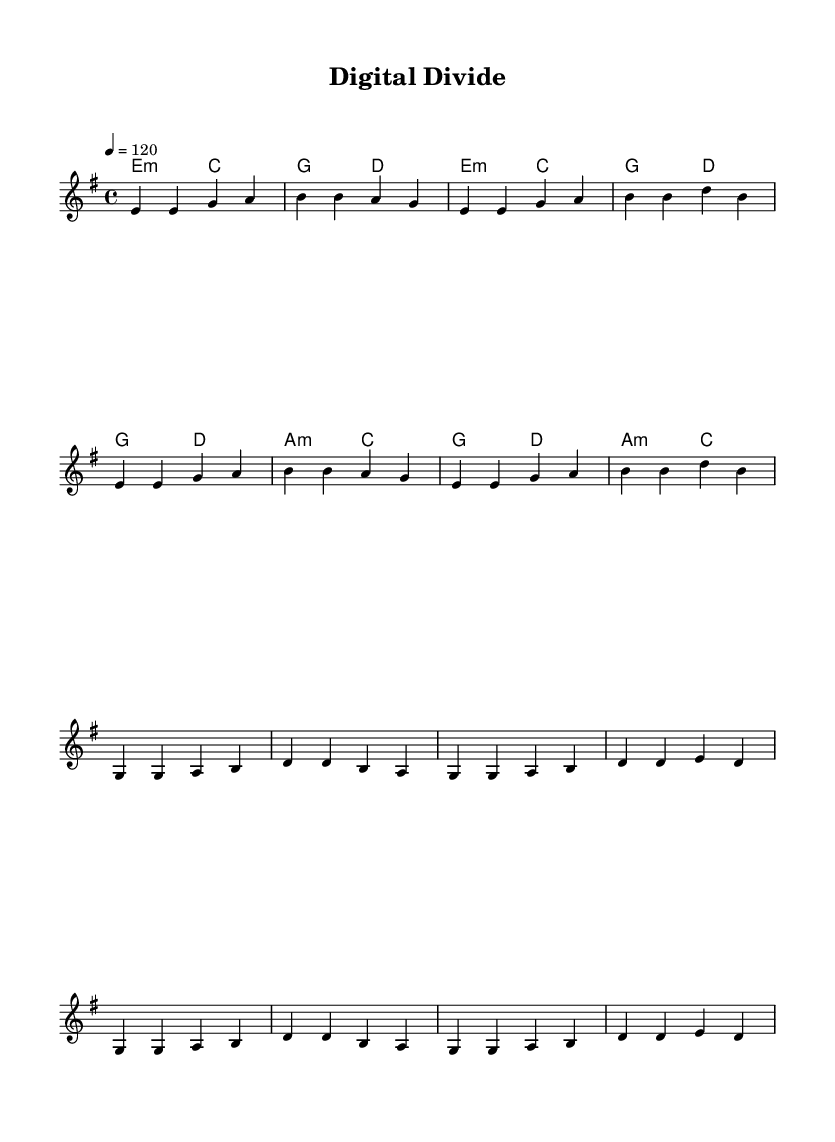What is the key signature of this music? The key signature is E minor, which has one sharp (F#) indicated at the beginning of the staff.
Answer: E minor What is the time signature of the piece? The time signature is 4/4, which is indicated at the beginning of the score and suggests that there are four beats in each measure.
Answer: 4/4 What is the tempo marking for this piece? The tempo marking is a quarter note equals 120, meaning the piece should be played at a speed of 120 beats per minute.
Answer: 120 How many measures are in the verse? The verse consists of four measures, clearly indicated by the grouping in the score for the melody and lyrics.
Answer: 4 What chord follows E minor in the verse progression? The chord that follows E minor in the verse progression is C major, as seen in the chord names above the melody.
Answer: C major What is the primary theme of the lyrics? The primary theme of the lyrics discusses the relationship between digital connectivity and human interaction, framed by the imagery of screens and static.
Answer: Connection What type of song structure is represented in this piece? The song structure consists of verses followed by a chorus, which is a common structure in rock music, designed to alternate between narrative and a repeated thematic statement.
Answer: Verse-Chorus 